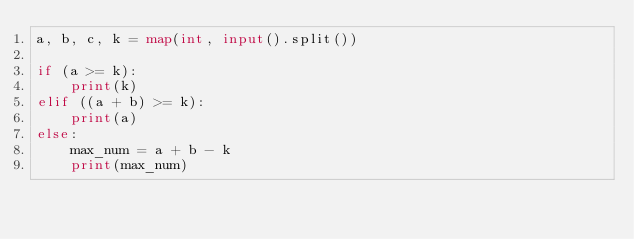Convert code to text. <code><loc_0><loc_0><loc_500><loc_500><_Python_>a, b, c, k = map(int, input().split())

if (a >= k):
    print(k)
elif ((a + b) >= k):
    print(a)
else:
    max_num = a + b - k
    print(max_num)</code> 